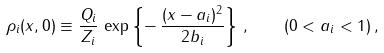Convert formula to latex. <formula><loc_0><loc_0><loc_500><loc_500>\rho _ { i } ( x , 0 ) \equiv \frac { Q _ { i } } { Z _ { i } } \, \exp \left \{ - \, \frac { ( x - a _ { i } ) ^ { 2 } } { 2 b _ { i } } \right \} \, , \quad ( 0 < a _ { i } < 1 ) \, ,</formula> 